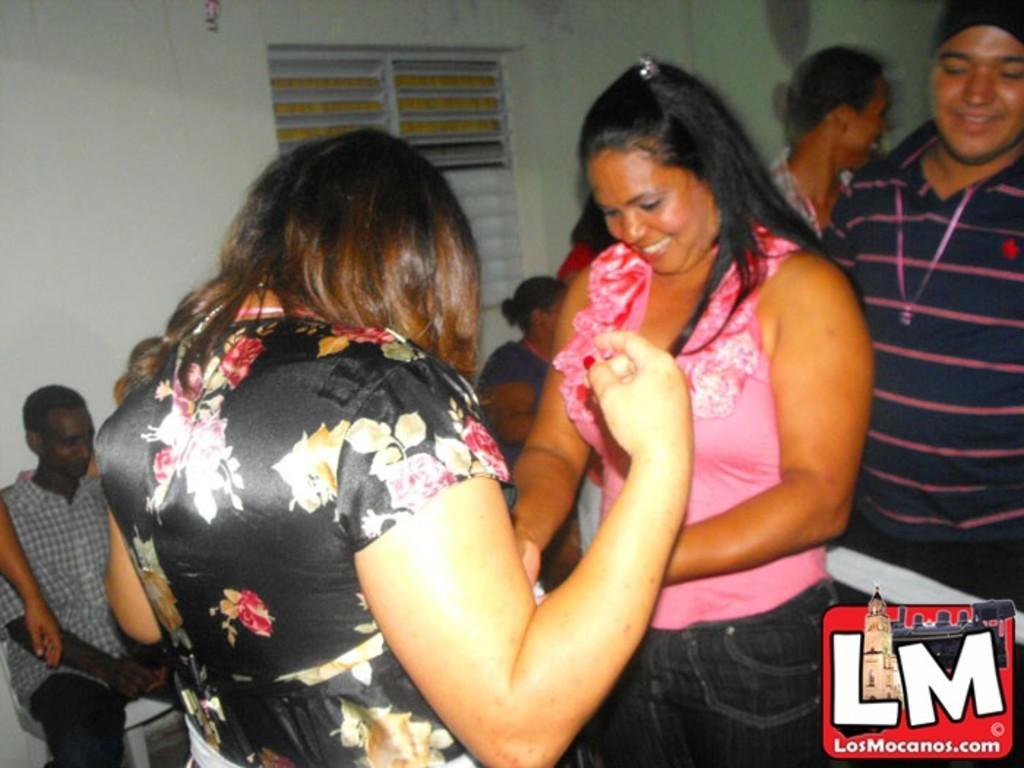In one or two sentences, can you explain what this image depicts? In this picture we can see group of people, few are sitting on the chairs and few are standing, in the bottom right hand corner we can see a logo and some text. 